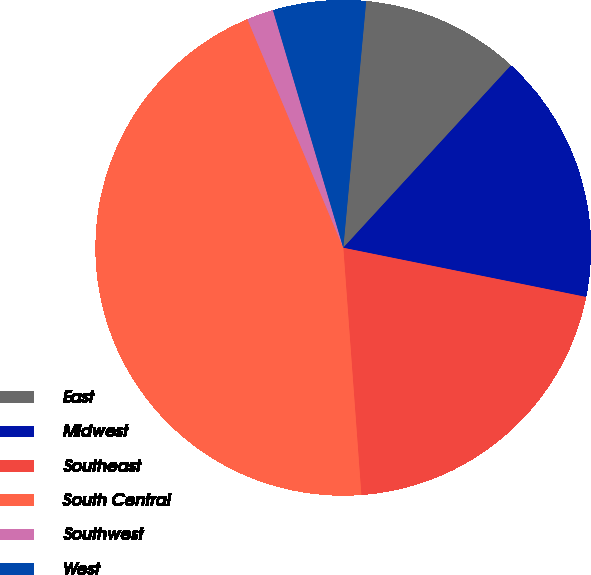Convert chart. <chart><loc_0><loc_0><loc_500><loc_500><pie_chart><fcel>East<fcel>Midwest<fcel>Southeast<fcel>South Central<fcel>Southwest<fcel>West<nl><fcel>10.36%<fcel>16.35%<fcel>20.66%<fcel>44.85%<fcel>1.74%<fcel>6.05%<nl></chart> 